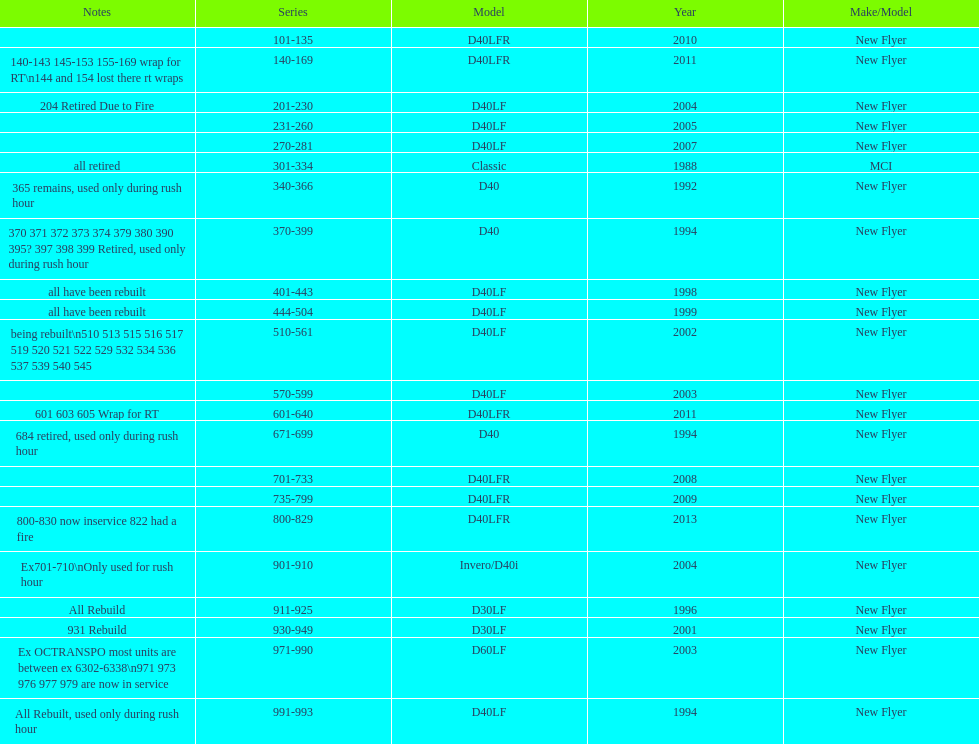Which buses are the newest in the current fleet? 800-829. 